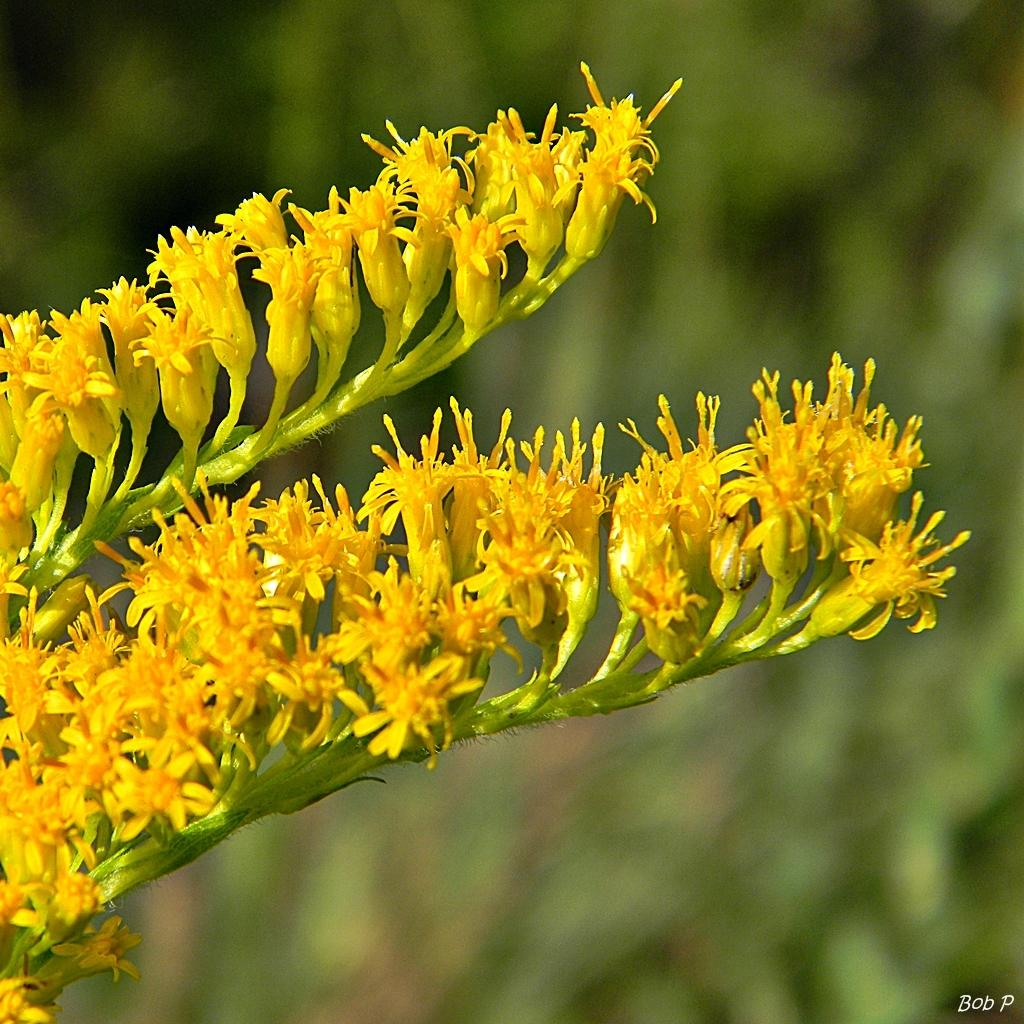What is present in the image? There is a plant in the image. What can be observed about the plant's flowers? The plant has yellow flowers. How many horses are visible in the image? There are no horses present in the image; it features a plant with yellow flowers. Can you tell me how many frogs are sitting on the plant's leaves? There are no frogs present in the image; it features a plant with yellow flowers. 